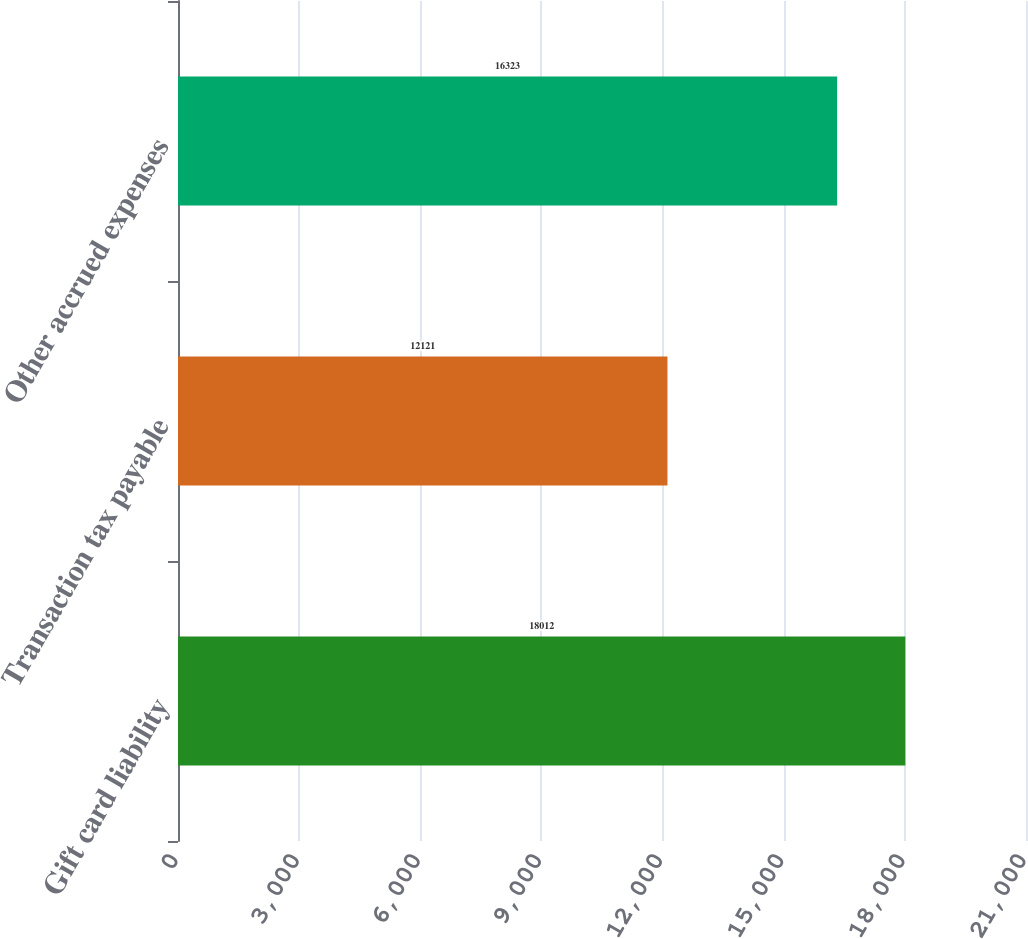<chart> <loc_0><loc_0><loc_500><loc_500><bar_chart><fcel>Gift card liability<fcel>Transaction tax payable<fcel>Other accrued expenses<nl><fcel>18012<fcel>12121<fcel>16323<nl></chart> 